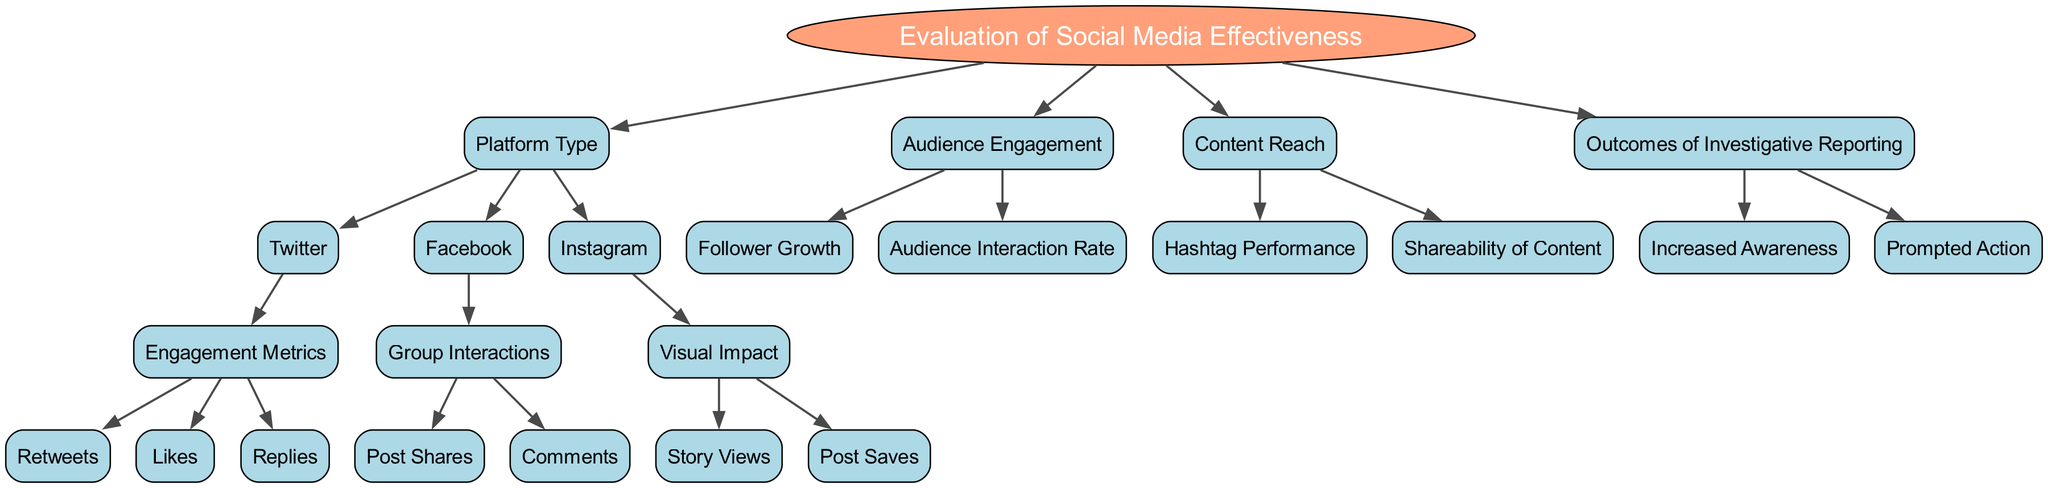What is the main topic of the decision tree? The root of the decision tree clearly states that the main topic is about the "Evaluation of Social Media Effectiveness." This answer is derived directly from the "Root" node in the diagram.
Answer: Evaluation of Social Media Effectiveness How many main evaluation areas are identified in this diagram? The diagram branches out into four main evaluation areas from the root node, which are: Platform Type, Audience Engagement, Content Reach, and Outcomes of Investigative Reporting. Thus, there are four main areas identified.
Answer: 4 Which social media platform focuses on engagement metrics specifically? The diagram indicates that "Twitter" is the platform that branches into "Engagement Metrics," which includes sub-nodes such as Retweets, Likes, and Replies. This relationship is directly indicated in the structure of the tree.
Answer: Twitter What are the sub-metrics listed under Engagement Metrics for Twitter? Under the "Engagement Metrics" node specifically for Twitter, there are three sub-nodes: Retweets, Likes, and Replies. This information is derived from the children of the "Engagement Metrics" node.
Answer: Retweets, Likes, Replies Which platform includes Group Interactions as a metric? According to the diagram, "Facebook" is the platform that has "Group Interactions" listed as one of its metrics, which further breaks down into Post Shares and Comments. This is evident from the child nodes of the Facebook node.
Answer: Facebook What is the outcome associated with increased awareness in investigative reporting? The diagram specifies that "Increased Awareness" is part of the larger category "Outcomes of Investigative Reporting." Therefore, the direct relationship represents the outcome directly connected to this evaluation area.
Answer: Increased Awareness How are the social media platforms categorized in the diagram? The platforms are categorized under the node "Platform Type," which includes specific branches for Twitter, Facebook, and Instagram. This categorization is evident as these platforms are clearly delineated under the specified node.
Answer: Platform Type What common characteristic is shared by the metrics listed under the Content Reach node? Both "Hashtag Performance" and "Shareability of Content" under the "Content Reach" node are metrics that evaluate how effectively content can be disseminated and engaged with across platforms, indicating their common characteristic as measures of content distribution effectiveness.
Answer: Content distribution effectiveness 